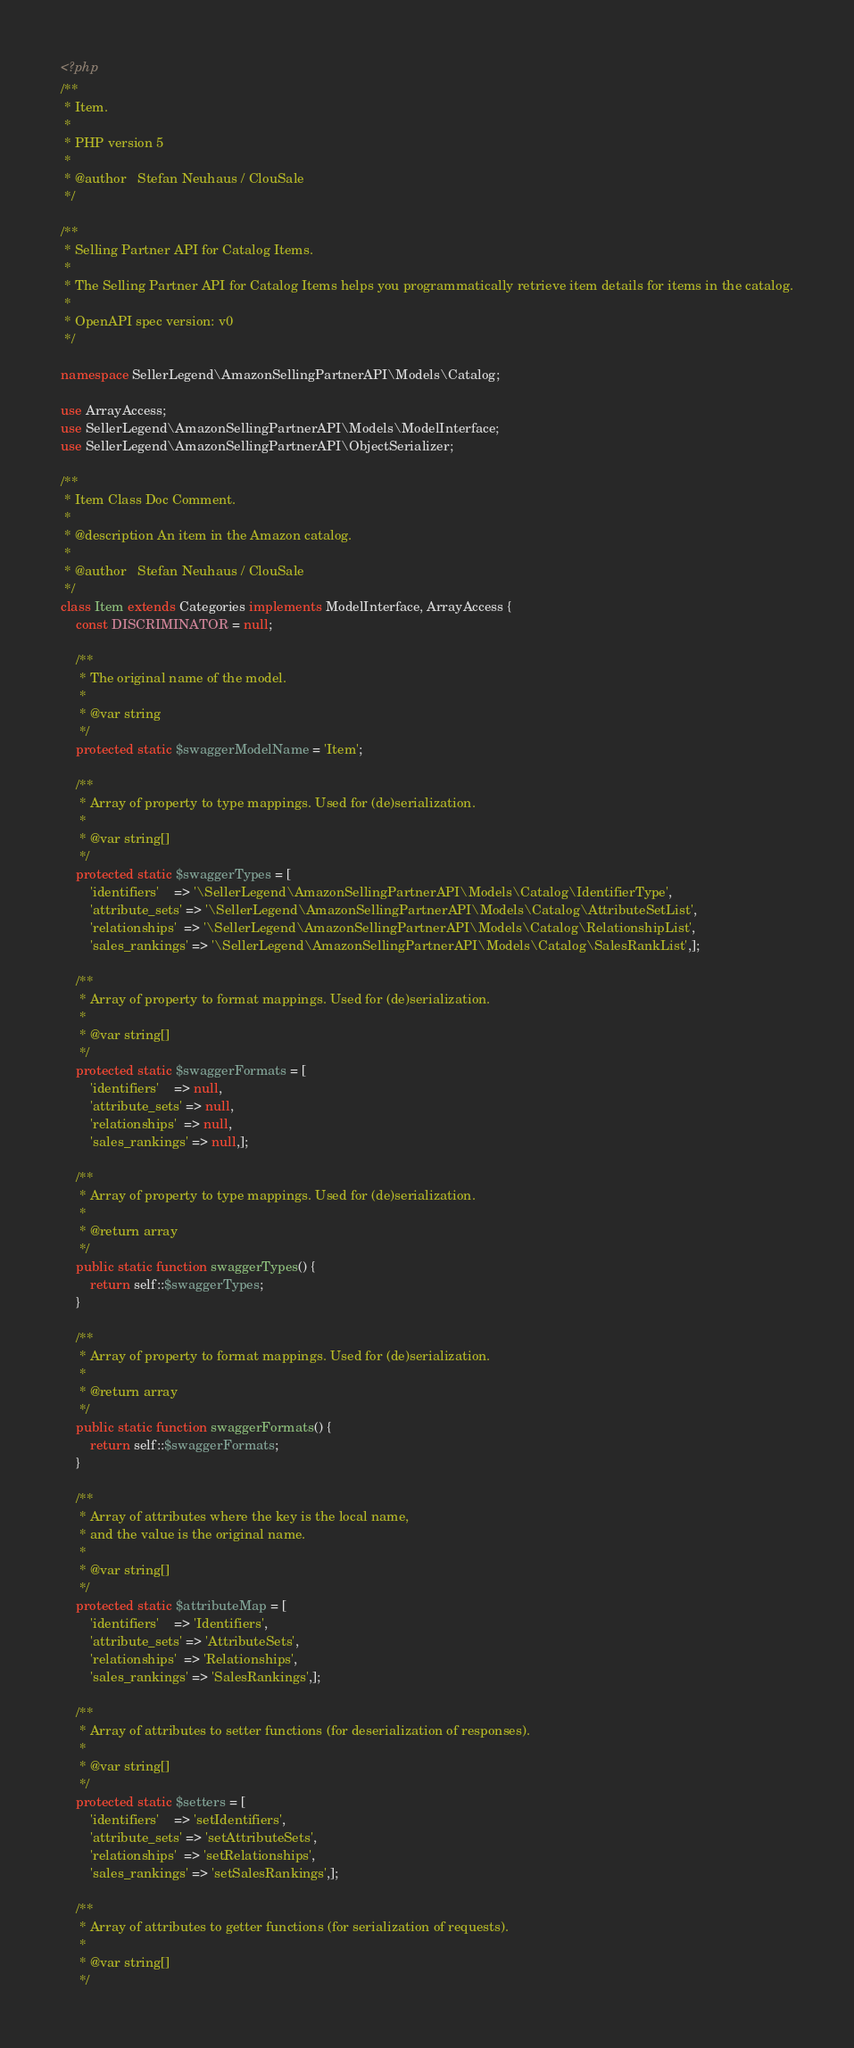Convert code to text. <code><loc_0><loc_0><loc_500><loc_500><_PHP_><?php
/**
 * Item.
 *
 * PHP version 5
 *
 * @author   Stefan Neuhaus / ClouSale
 */

/**
 * Selling Partner API for Catalog Items.
 *
 * The Selling Partner API for Catalog Items helps you programmatically retrieve item details for items in the catalog.
 *
 * OpenAPI spec version: v0
 */

namespace SellerLegend\AmazonSellingPartnerAPI\Models\Catalog;

use ArrayAccess;
use SellerLegend\AmazonSellingPartnerAPI\Models\ModelInterface;
use SellerLegend\AmazonSellingPartnerAPI\ObjectSerializer;

/**
 * Item Class Doc Comment.
 *
 * @description An item in the Amazon catalog.
 *
 * @author   Stefan Neuhaus / ClouSale
 */
class Item extends Categories implements ModelInterface, ArrayAccess {
    const DISCRIMINATOR = null;

    /**
     * The original name of the model.
     *
     * @var string
     */
    protected static $swaggerModelName = 'Item';

    /**
     * Array of property to type mappings. Used for (de)serialization.
     *
     * @var string[]
     */
    protected static $swaggerTypes = [
        'identifiers'    => '\SellerLegend\AmazonSellingPartnerAPI\Models\Catalog\IdentifierType',
        'attribute_sets' => '\SellerLegend\AmazonSellingPartnerAPI\Models\Catalog\AttributeSetList',
        'relationships'  => '\SellerLegend\AmazonSellingPartnerAPI\Models\Catalog\RelationshipList',
        'sales_rankings' => '\SellerLegend\AmazonSellingPartnerAPI\Models\Catalog\SalesRankList',];

    /**
     * Array of property to format mappings. Used for (de)serialization.
     *
     * @var string[]
     */
    protected static $swaggerFormats = [
        'identifiers'    => null,
        'attribute_sets' => null,
        'relationships'  => null,
        'sales_rankings' => null,];

    /**
     * Array of property to type mappings. Used for (de)serialization.
     *
     * @return array
     */
    public static function swaggerTypes() {
        return self::$swaggerTypes;
    }

    /**
     * Array of property to format mappings. Used for (de)serialization.
     *
     * @return array
     */
    public static function swaggerFormats() {
        return self::$swaggerFormats;
    }

    /**
     * Array of attributes where the key is the local name,
     * and the value is the original name.
     *
     * @var string[]
     */
    protected static $attributeMap = [
        'identifiers'    => 'Identifiers',
        'attribute_sets' => 'AttributeSets',
        'relationships'  => 'Relationships',
        'sales_rankings' => 'SalesRankings',];

    /**
     * Array of attributes to setter functions (for deserialization of responses).
     *
     * @var string[]
     */
    protected static $setters = [
        'identifiers'    => 'setIdentifiers',
        'attribute_sets' => 'setAttributeSets',
        'relationships'  => 'setRelationships',
        'sales_rankings' => 'setSalesRankings',];

    /**
     * Array of attributes to getter functions (for serialization of requests).
     *
     * @var string[]
     */</code> 